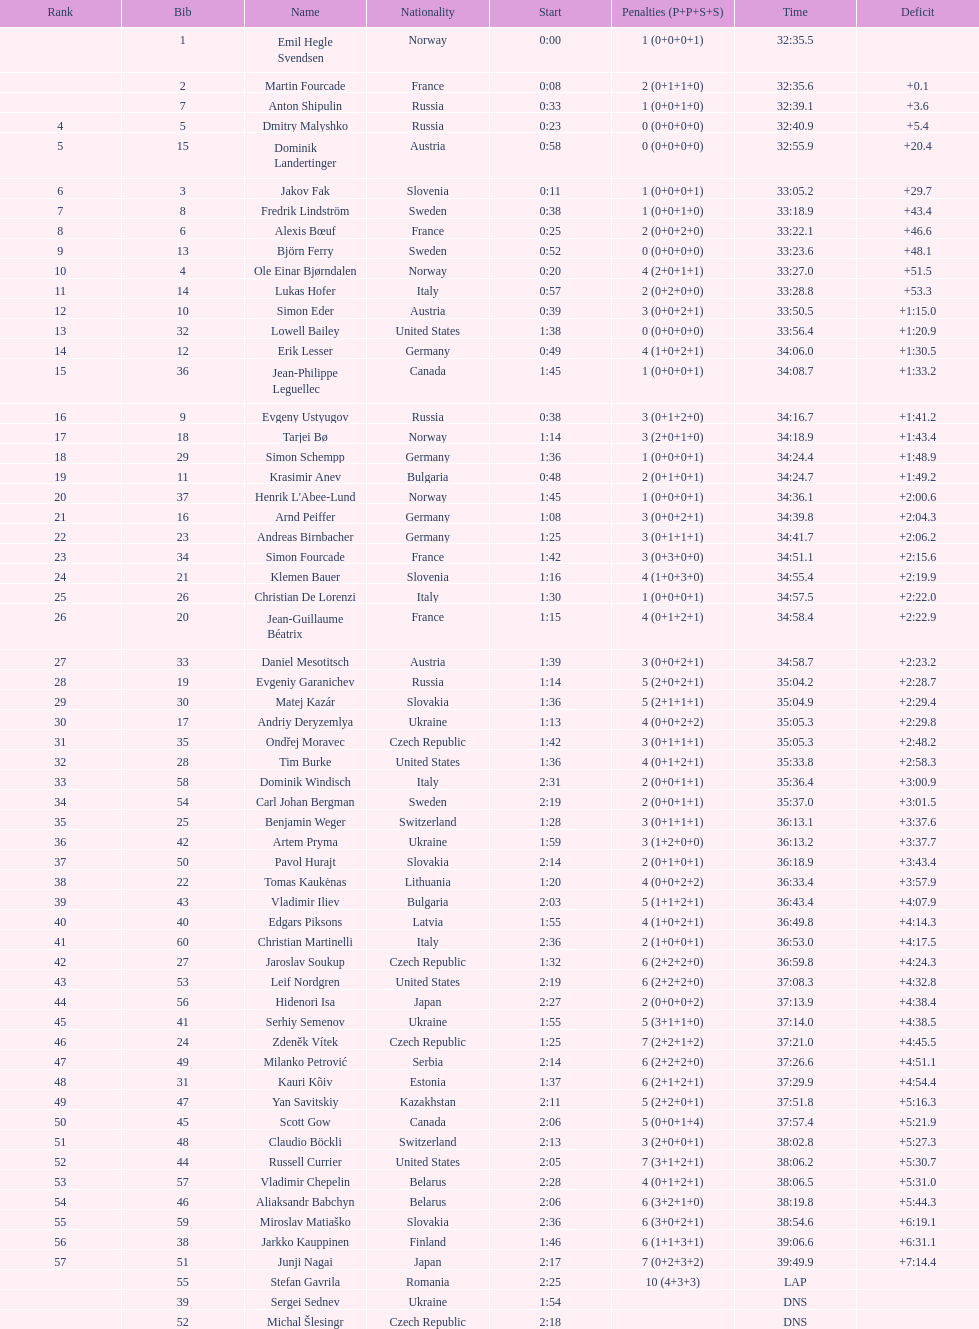What is the number of russian participants? 4. 